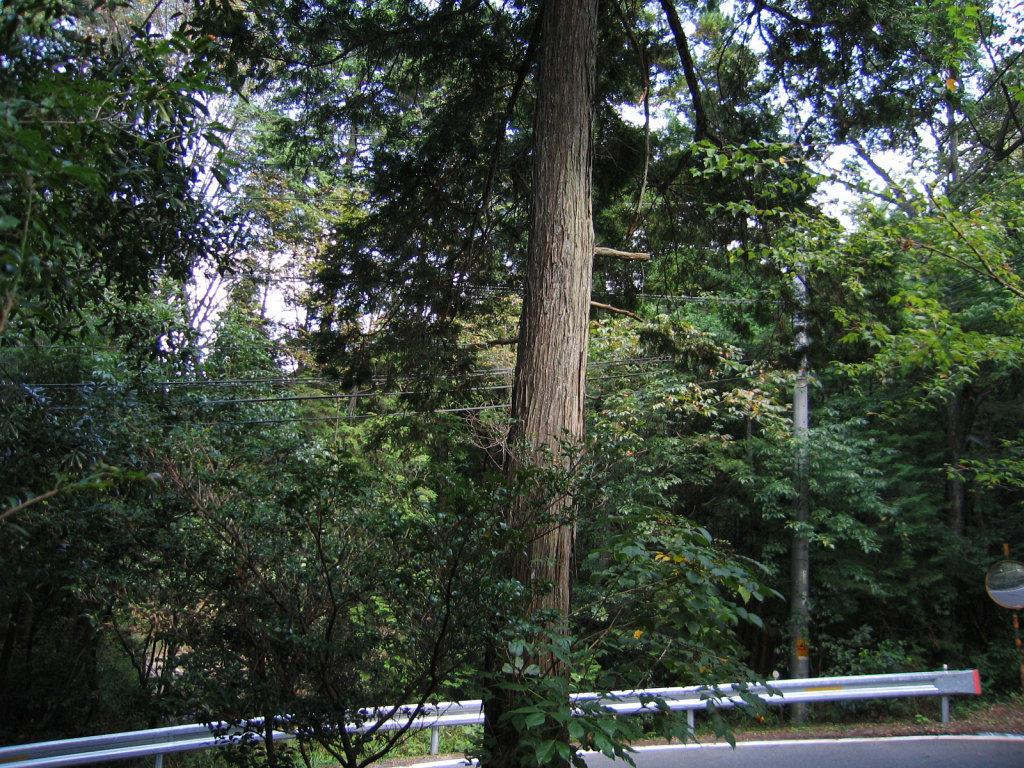What part of a tree can be seen in the image? The bark of a tree is visible in the image. What type of structures are present in the image? There are metal poles in the image. What can be found on the metal poles? A signboard is present in the image. How many trees are visible in the image? There is a group of trees in the image. What else can be seen in the image besides trees and metal poles? Wires are visible in the image. What is the condition of the sky in the image? The sky is visible in the image, and it appears cloudy. Can you see the representative's eyes in the image? There is no representative present in the image, so their eyes cannot be seen. What type of furniture is visible in the bedroom in the image? There is no bedroom present in the image, so no furniture can be seen. 